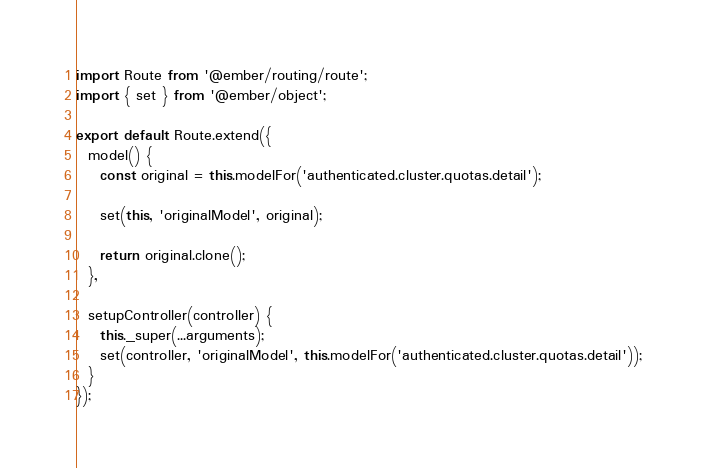Convert code to text. <code><loc_0><loc_0><loc_500><loc_500><_JavaScript_>import Route from '@ember/routing/route';
import { set } from '@ember/object';

export default Route.extend({
  model() {
    const original = this.modelFor('authenticated.cluster.quotas.detail');

    set(this, 'originalModel', original);

    return original.clone();
  },

  setupController(controller) {
    this._super(...arguments);
    set(controller, 'originalModel', this.modelFor('authenticated.cluster.quotas.detail'));
  }
});
</code> 